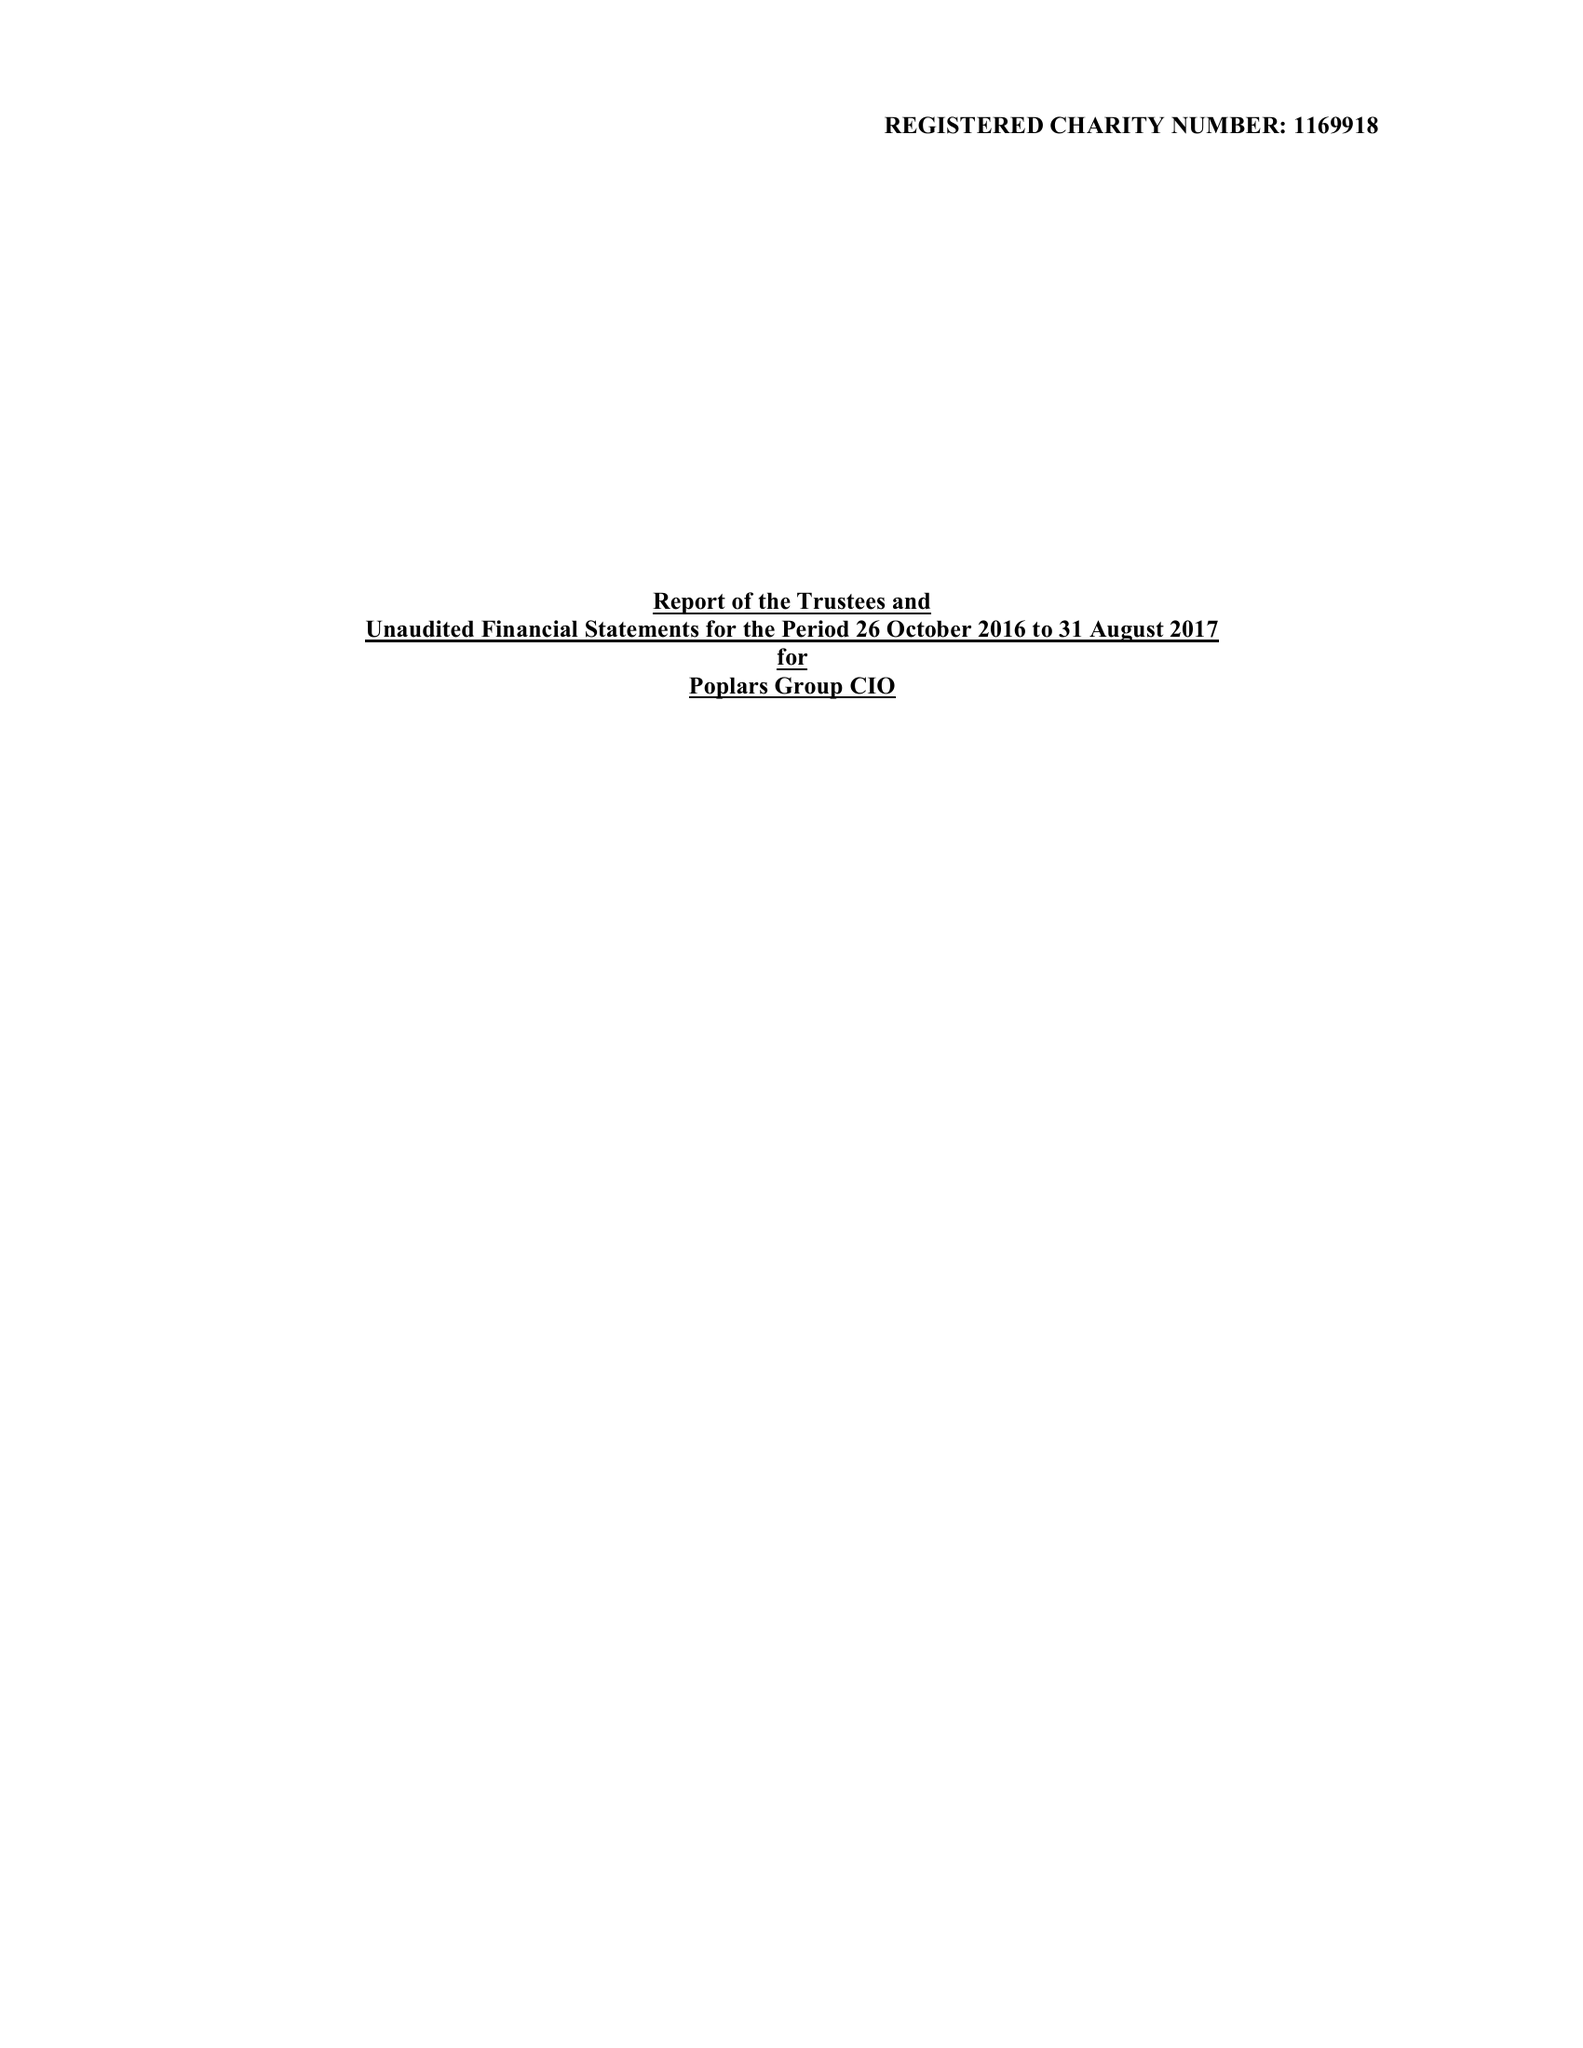What is the value for the address__postcode?
Answer the question using a single word or phrase. LE18 1DB 